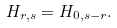<formula> <loc_0><loc_0><loc_500><loc_500>H _ { r , s } = H _ { 0 , s - r } .</formula> 